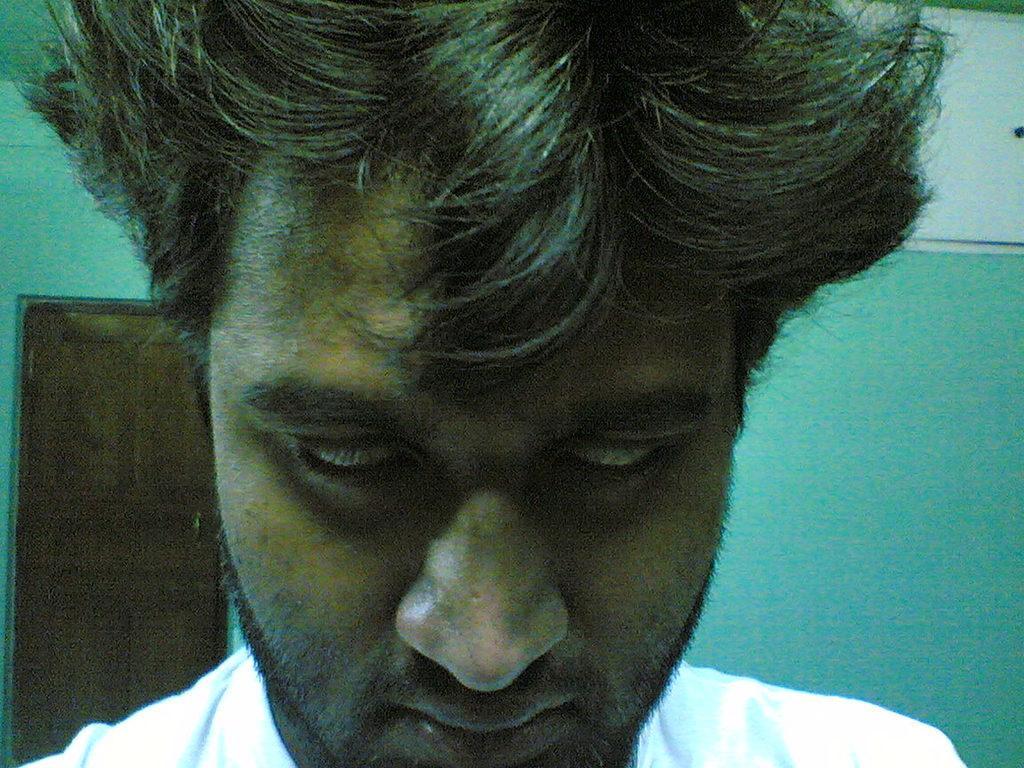Describe this image in one or two sentences. In this image we can see a man. In the background, we can see a door and the wall. 